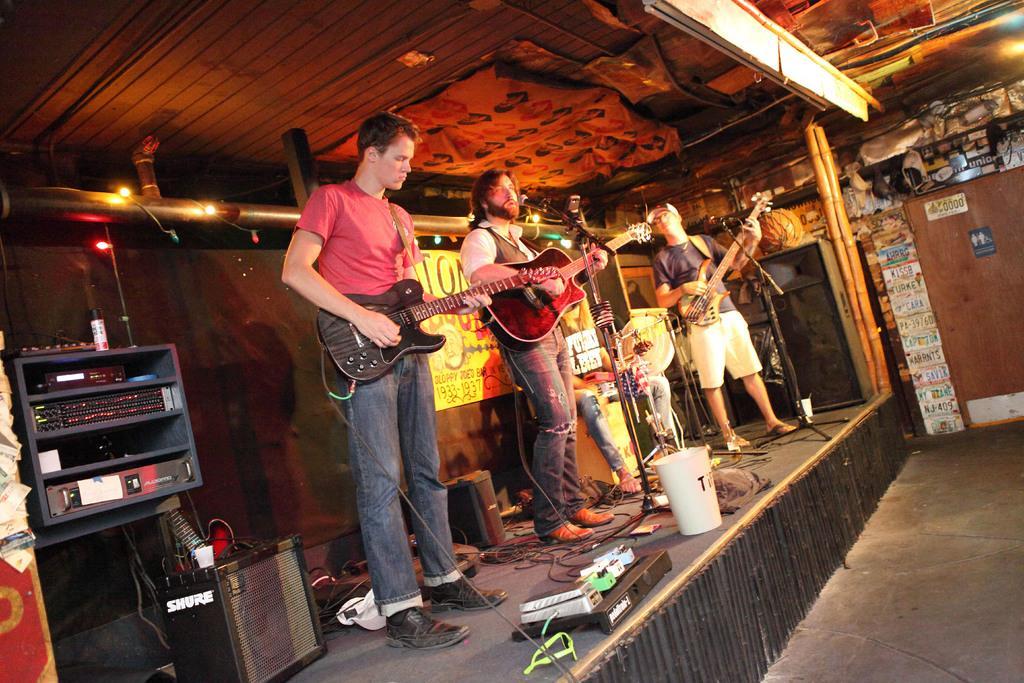Describe this image in one or two sentences. In this picture we can see four men where three are standing on stage holding guitars in their hands and playing it and in middle person singing on mic and on stage we can see bucket, speakers, devices, wires and in background we can see wall with banners, stickers, pole. 